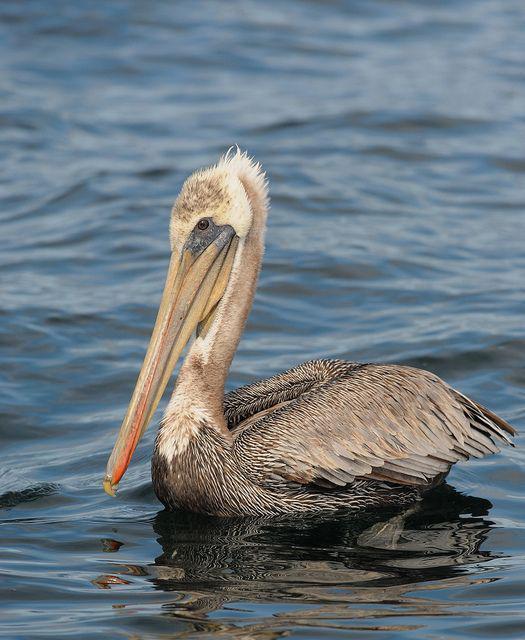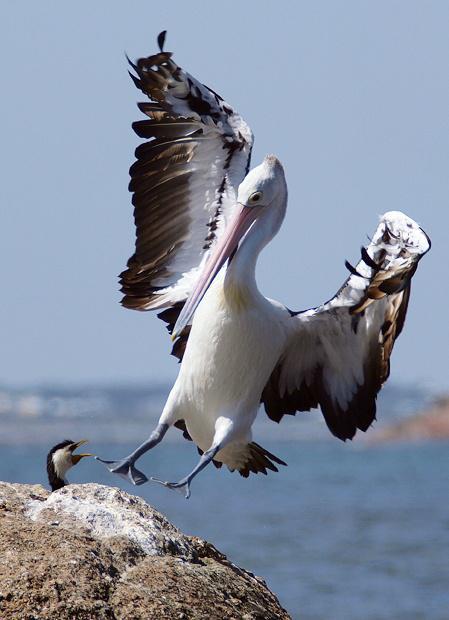The first image is the image on the left, the second image is the image on the right. Evaluate the accuracy of this statement regarding the images: "A bird is sitting on water.". Is it true? Answer yes or no. Yes. 